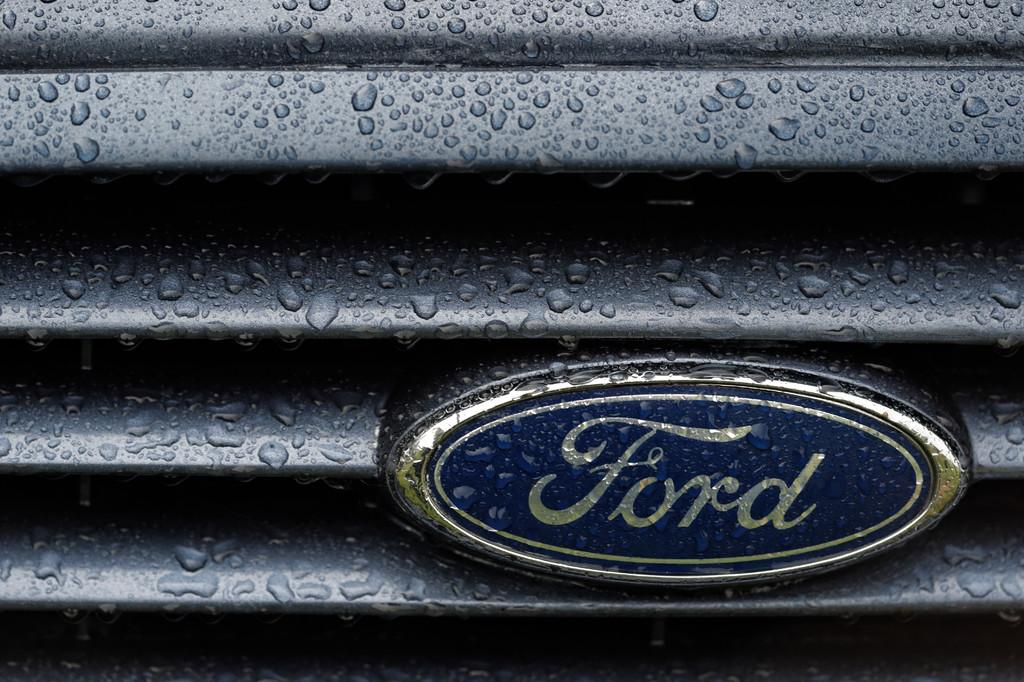What is the main subject in the front of the image? There is an object in the front of the image. What color is the object? The object is black in color. What else can be observed on the object? There is text written on the object. How many toys are scattered around the object in the image? There are no toys present in the image. Is there a shoe visible near the object in the image? There is no shoe visible near the object in the image. 